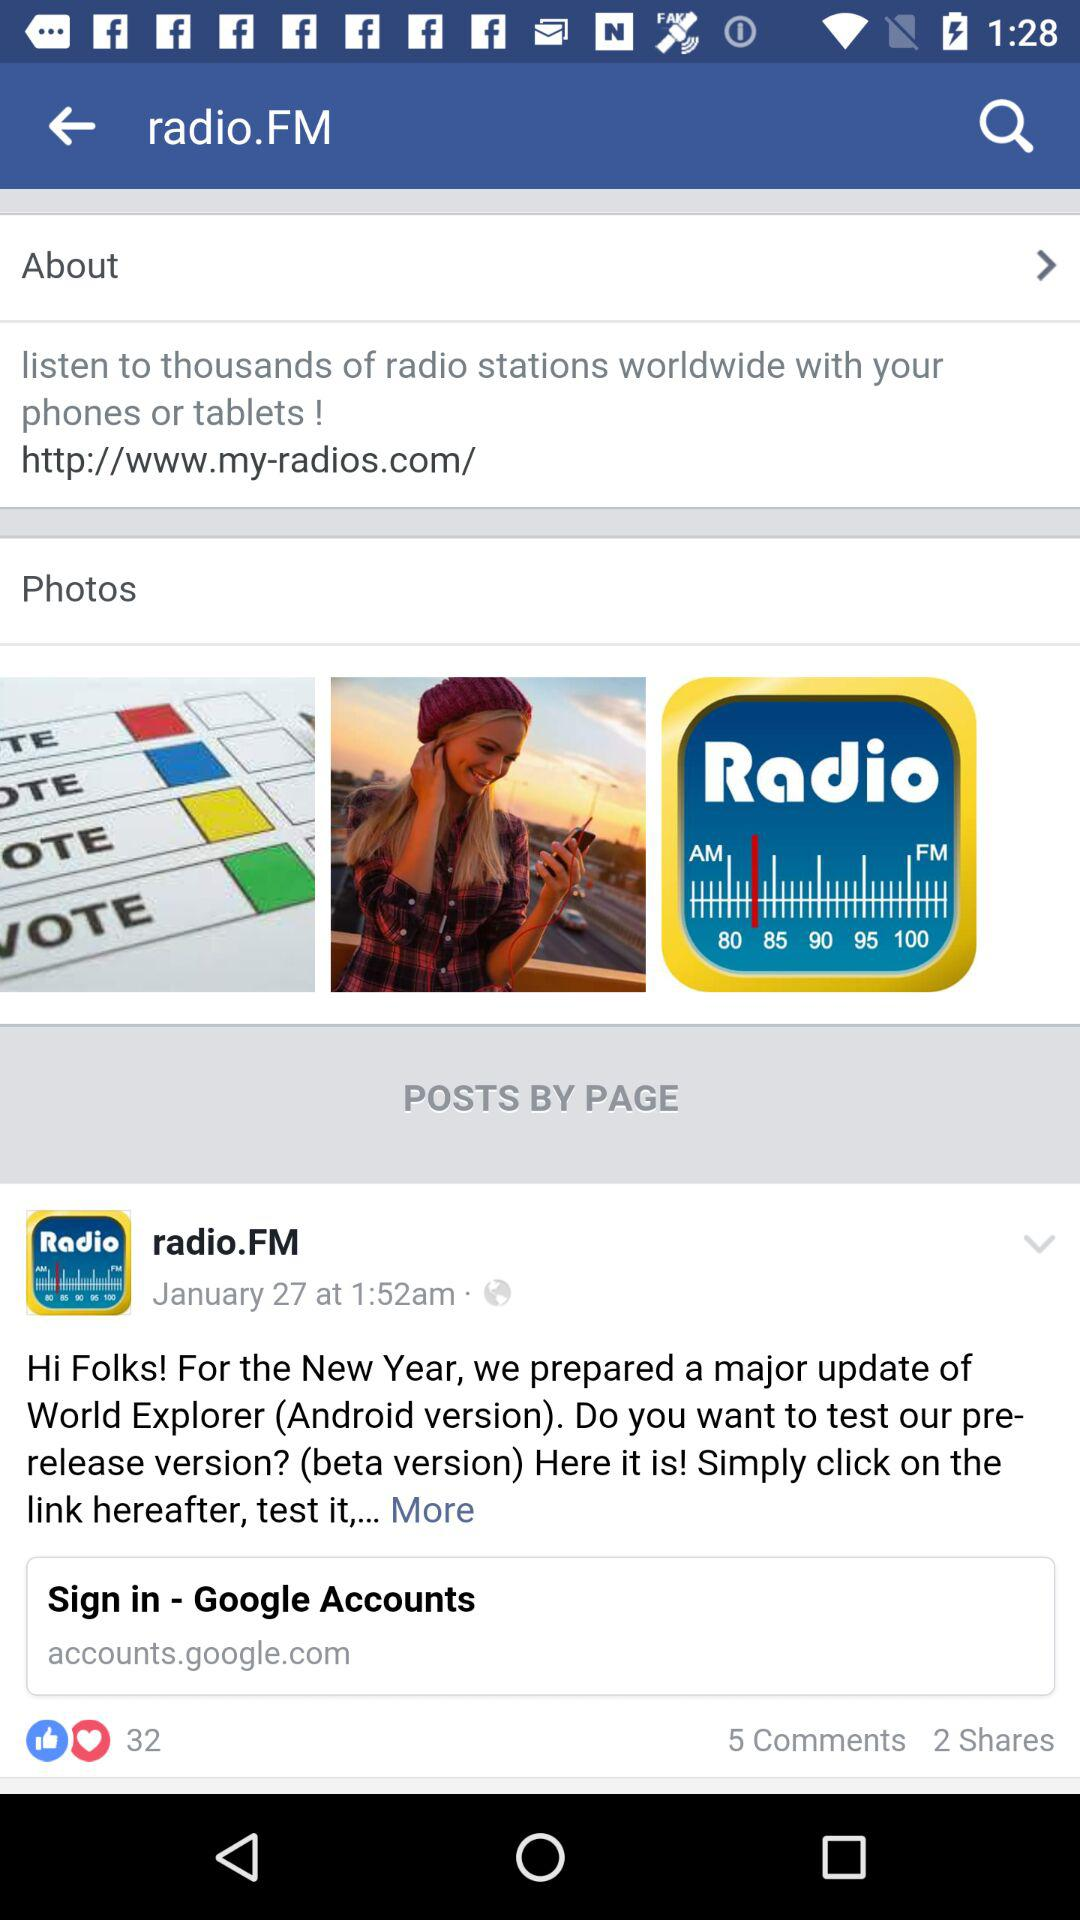What is the date shown on the screen? The date shown on the screen is January 27. 